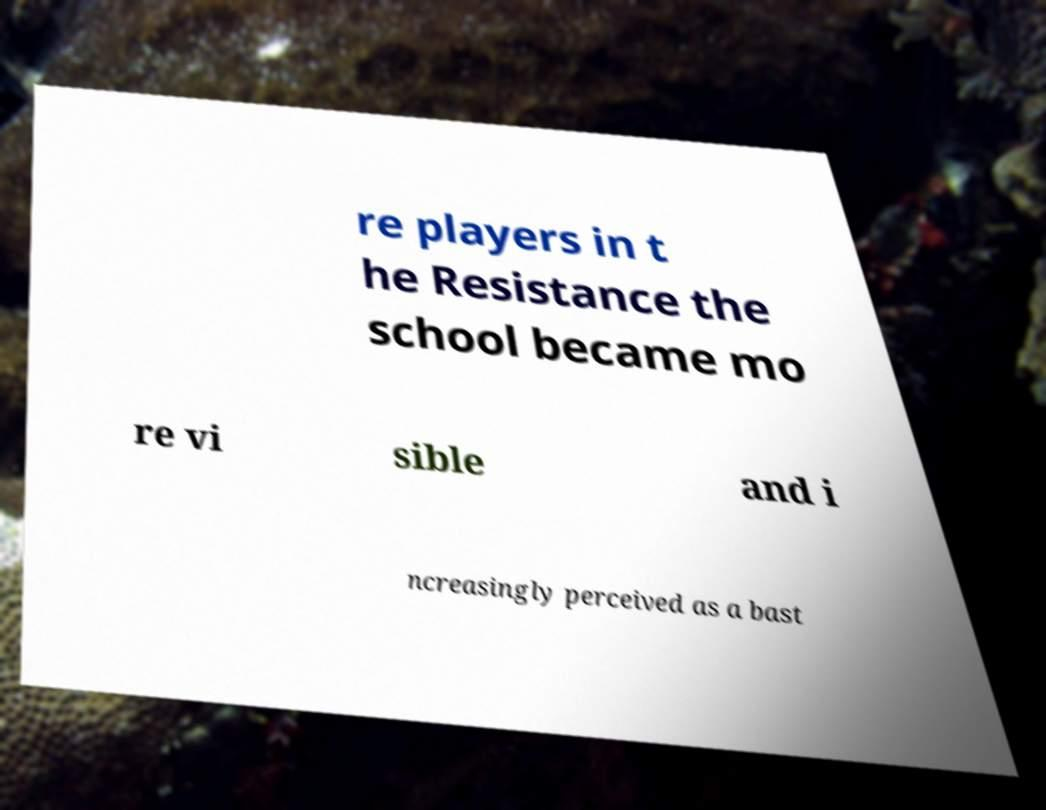There's text embedded in this image that I need extracted. Can you transcribe it verbatim? re players in t he Resistance the school became mo re vi sible and i ncreasingly perceived as a bast 